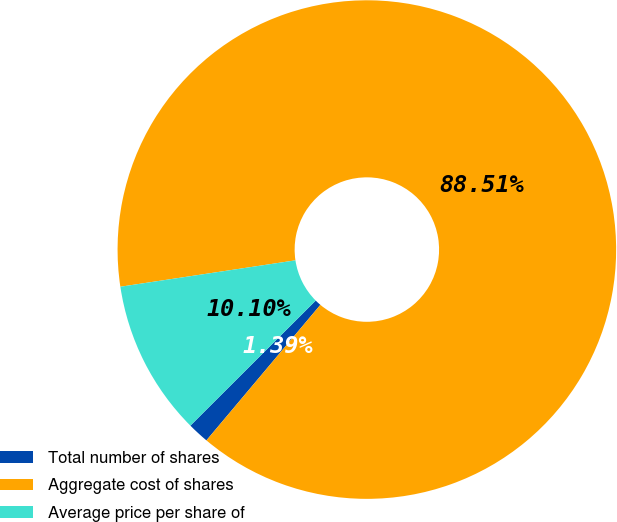Convert chart. <chart><loc_0><loc_0><loc_500><loc_500><pie_chart><fcel>Total number of shares<fcel>Aggregate cost of shares<fcel>Average price per share of<nl><fcel>1.39%<fcel>88.5%<fcel>10.1%<nl></chart> 